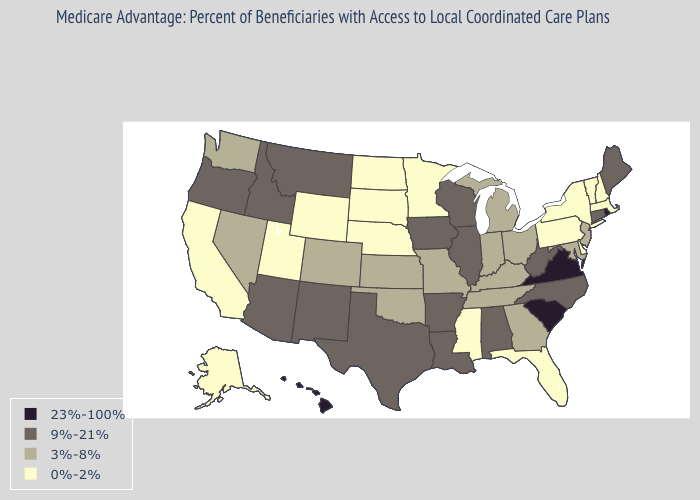Among the states that border Michigan , which have the lowest value?
Quick response, please. Indiana, Ohio. Does Oregon have a higher value than New York?
Be succinct. Yes. Name the states that have a value in the range 0%-2%?
Write a very short answer. Alaska, California, Delaware, Florida, Massachusetts, Minnesota, Mississippi, North Dakota, Nebraska, New Hampshire, New York, Pennsylvania, South Dakota, Utah, Vermont, Wyoming. Name the states that have a value in the range 0%-2%?
Short answer required. Alaska, California, Delaware, Florida, Massachusetts, Minnesota, Mississippi, North Dakota, Nebraska, New Hampshire, New York, Pennsylvania, South Dakota, Utah, Vermont, Wyoming. Does Oklahoma have a higher value than Connecticut?
Concise answer only. No. Among the states that border Tennessee , does Virginia have the highest value?
Answer briefly. Yes. Does Nevada have the highest value in the USA?
Keep it brief. No. What is the value of Alabama?
Keep it brief. 9%-21%. What is the highest value in states that border New Hampshire?
Answer briefly. 9%-21%. What is the lowest value in the USA?
Give a very brief answer. 0%-2%. What is the lowest value in the USA?
Short answer required. 0%-2%. What is the highest value in states that border Mississippi?
Short answer required. 9%-21%. What is the value of Nebraska?
Give a very brief answer. 0%-2%. What is the lowest value in states that border Wisconsin?
Concise answer only. 0%-2%. Among the states that border Nevada , which have the lowest value?
Write a very short answer. California, Utah. 